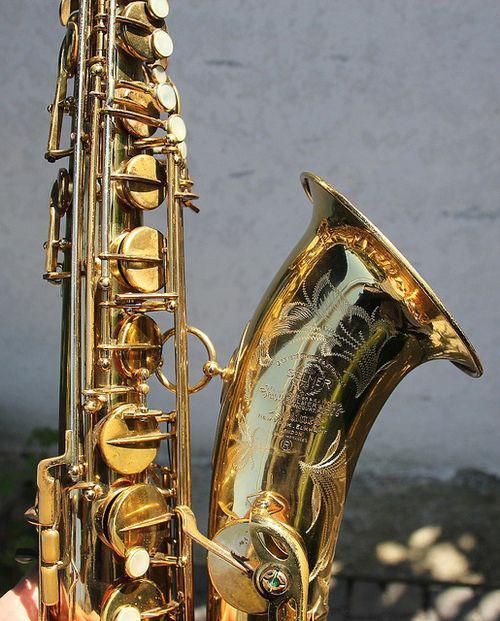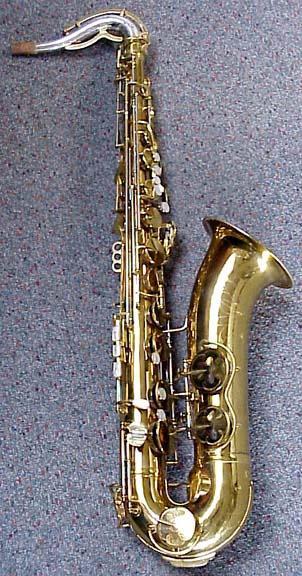The first image is the image on the left, the second image is the image on the right. Analyze the images presented: Is the assertion "There are only two saxophones." valid? Answer yes or no. Yes. 